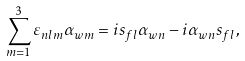<formula> <loc_0><loc_0><loc_500><loc_500>\sum _ { m = 1 } ^ { 3 } \varepsilon _ { n l m } \alpha _ { w m } = i s _ { f l } \alpha _ { w n } - i \alpha _ { w n } s _ { f l } ,</formula> 